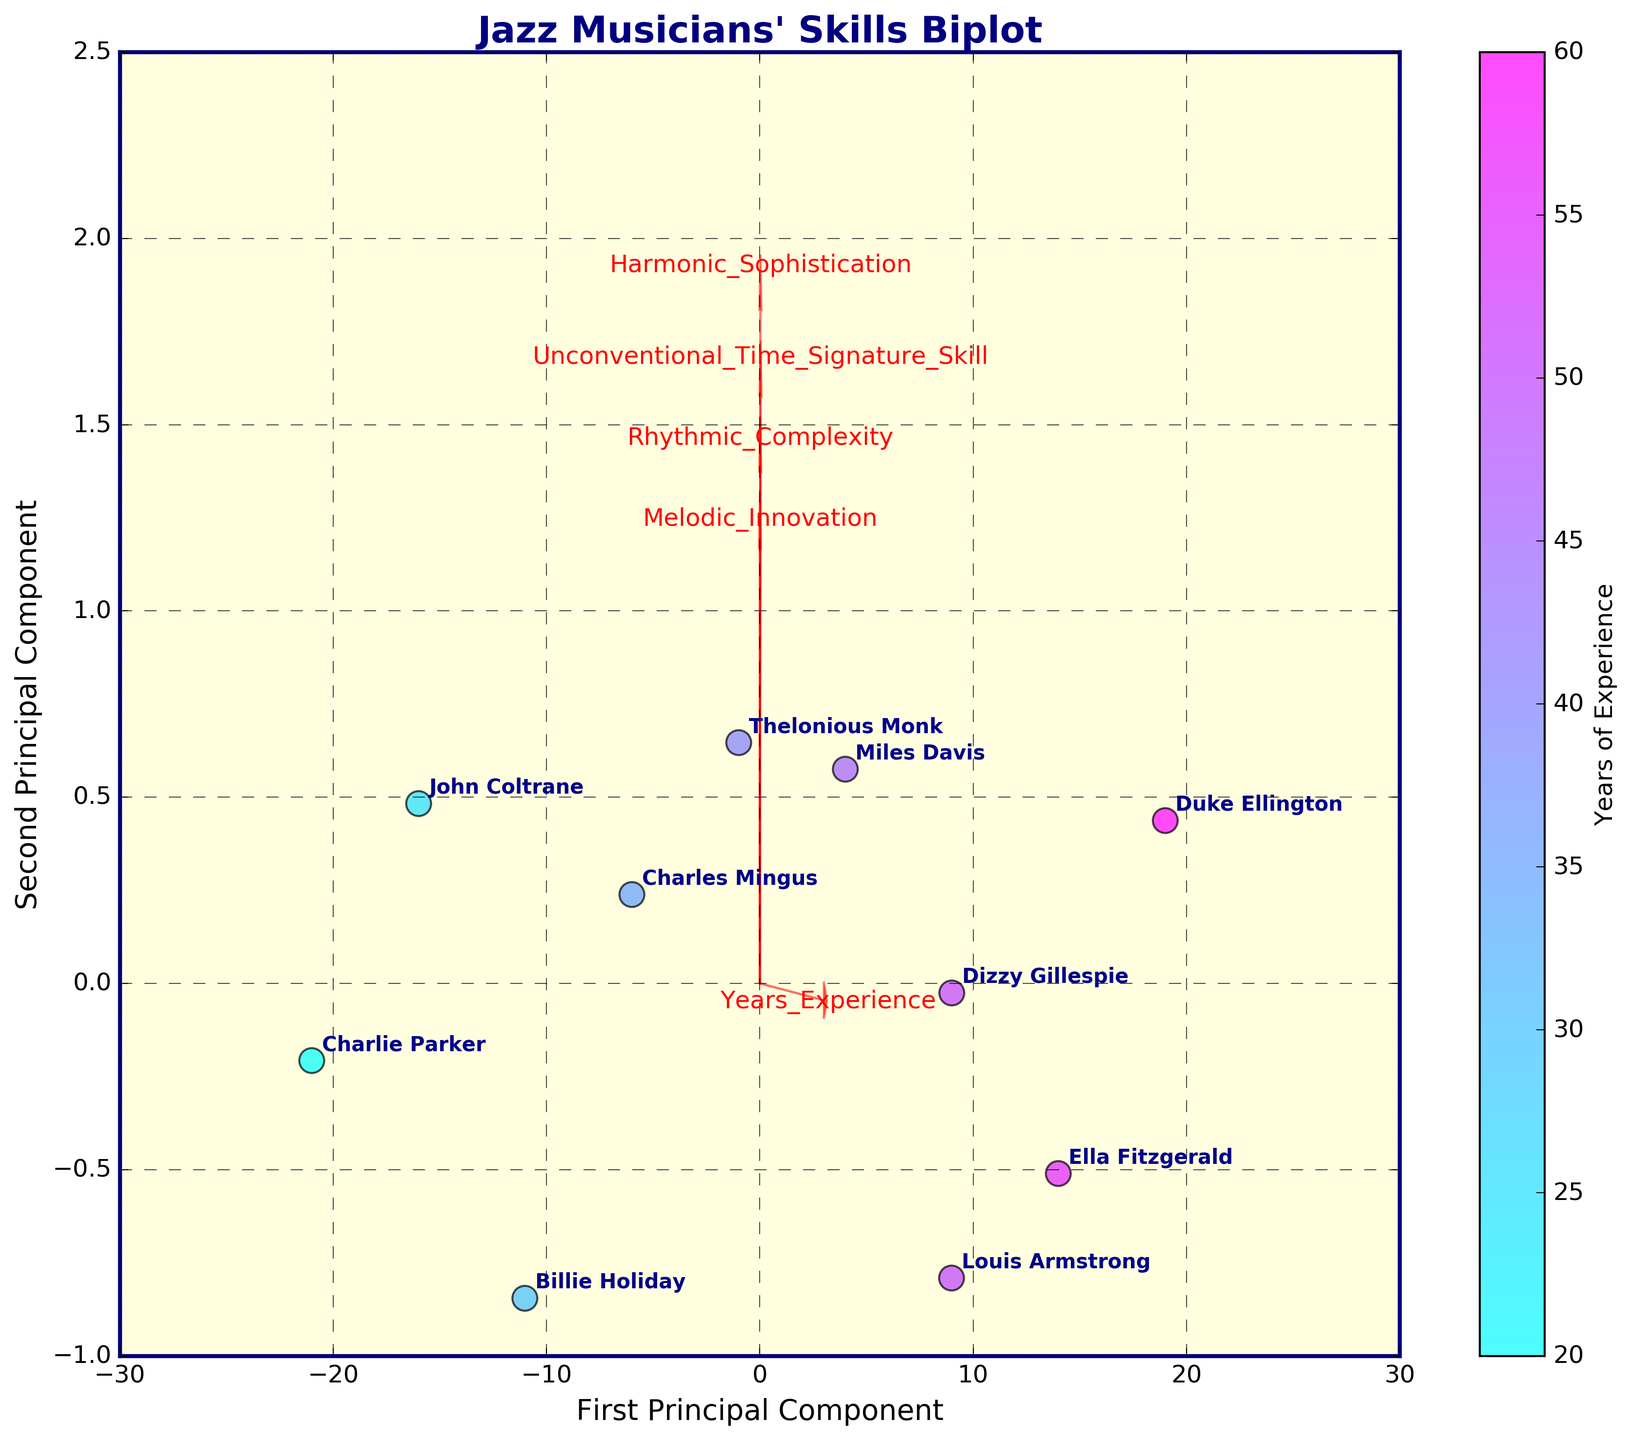How many musical features are depicted as vectors in the biplot? The biplot includes arrows representing the different musical features. By counting the arrows, we can deduce the number of features being analyzed.
Answer: 5 What is the title of the biplot? The title is written at the top of the figure and provides an overview of what the visual represents.
Answer: "Jazz Musicians' Skills Biplot" Which musician has the highest value for the years of experience? By reading the labels and identifying the highest numerical value on the color gradient representing years of experience, we can find the musician with the highest experience.
Answer: Duke Ellington Which principal component seems to have the largest spread of data points? By observing the extent of the data points along both principal component axes, we can see which one has a wider range of values.
Answer: First Principal Component Can you identify a musician who scores high on the unconventional time signature skill but is relatively lower on years of experience? We look for data points positioned close to the vector for "Unconventional Time Signature Skill" with a lighter color indicating fewer years of experience.
Answer: Charlie Parker Which feature is most aligned with the first principal component? We determine which vector has the largest projection in the direction of the first principal component axis.
Answer: Rhythmic Complexity How do Miles Davis and Ella Fitzgerald compare in terms of the first two principal components? By locating the positions of both musicians on the biplot and comparing their coordinates along the first and second principal components, we can assess their differences.
Answer: Miles Davis is higher on the first principal component but similar on the second Is there any musician close to the origin of the biplot? The origin is the center of the biplot, and we need to find which musician's coordinate points are closest to (0,0).
Answer: Billie Holiday Which musician has the second-highest unconventional time signature skill and how many years of experience do they have? First, identify all values for unconventional time signature skill, rank them, then locate the relevant musician and their years of experience.
Answer: John Coltrane, 25 years Do musicians with more years of experience generally score higher in harmonic sophistication based on the biplot? By comparing the directions and lengths of vectors and the clustering of points, we can infer if a pattern exists between years of experience and harmonic sophistication.
Answer: Yes 